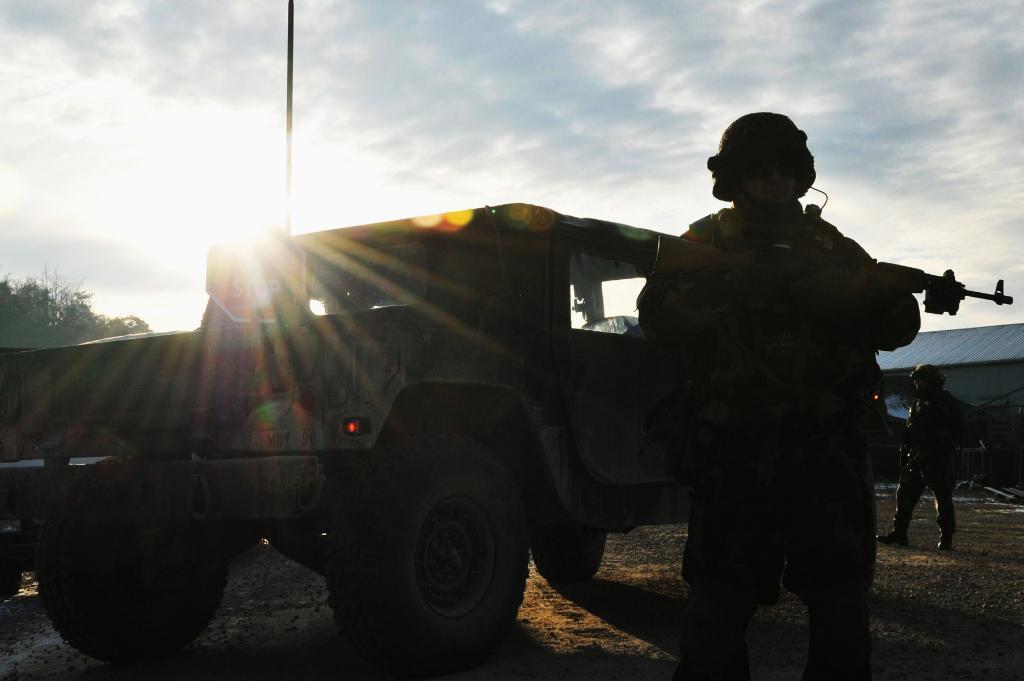Can you describe this image briefly? This picture shows a jeep and we see couple of men standing and they wore helmets on their heads and we see a man holding gun in his hand and we see a cloudy sky and a tree on the side and we see a house. 